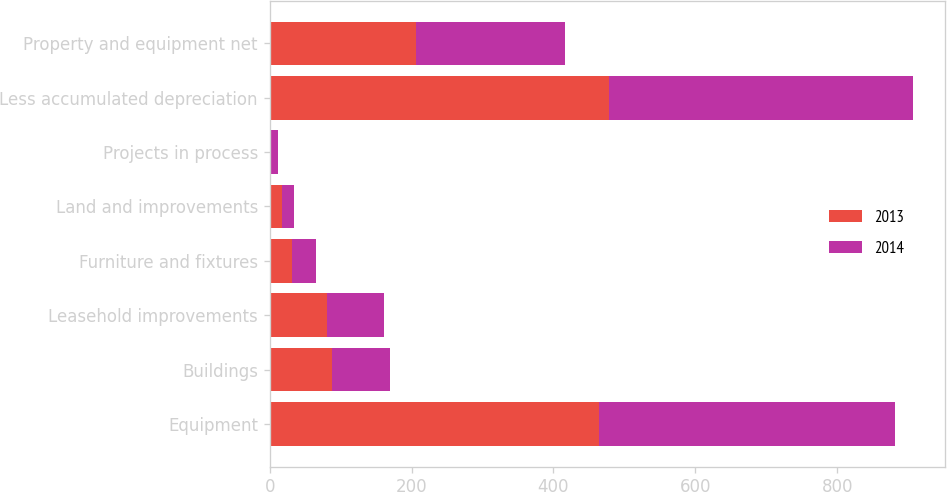Convert chart to OTSL. <chart><loc_0><loc_0><loc_500><loc_500><stacked_bar_chart><ecel><fcel>Equipment<fcel>Buildings<fcel>Leasehold improvements<fcel>Furniture and fixtures<fcel>Land and improvements<fcel>Projects in process<fcel>Less accumulated depreciation<fcel>Property and equipment net<nl><fcel>2013<fcel>464.6<fcel>87.8<fcel>81.1<fcel>32.2<fcel>17<fcel>2.2<fcel>478.5<fcel>206.4<nl><fcel>2014<fcel>416.1<fcel>82.3<fcel>80.3<fcel>33.3<fcel>16.9<fcel>9.6<fcel>428.6<fcel>209.9<nl></chart> 